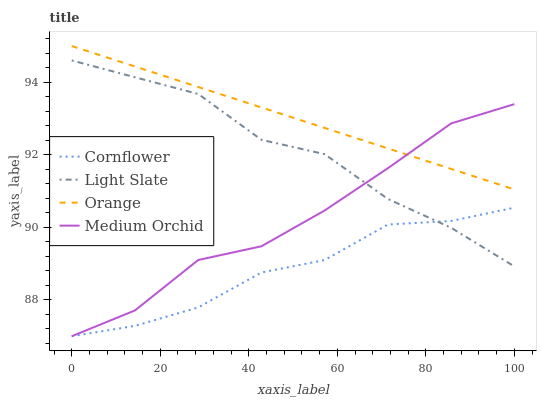Does Cornflower have the minimum area under the curve?
Answer yes or no. Yes. Does Orange have the maximum area under the curve?
Answer yes or no. Yes. Does Orange have the minimum area under the curve?
Answer yes or no. No. Does Cornflower have the maximum area under the curve?
Answer yes or no. No. Is Orange the smoothest?
Answer yes or no. Yes. Is Medium Orchid the roughest?
Answer yes or no. Yes. Is Cornflower the smoothest?
Answer yes or no. No. Is Cornflower the roughest?
Answer yes or no. No. Does Cornflower have the lowest value?
Answer yes or no. Yes. Does Orange have the lowest value?
Answer yes or no. No. Does Orange have the highest value?
Answer yes or no. Yes. Does Cornflower have the highest value?
Answer yes or no. No. Is Light Slate less than Orange?
Answer yes or no. Yes. Is Orange greater than Cornflower?
Answer yes or no. Yes. Does Orange intersect Medium Orchid?
Answer yes or no. Yes. Is Orange less than Medium Orchid?
Answer yes or no. No. Is Orange greater than Medium Orchid?
Answer yes or no. No. Does Light Slate intersect Orange?
Answer yes or no. No. 